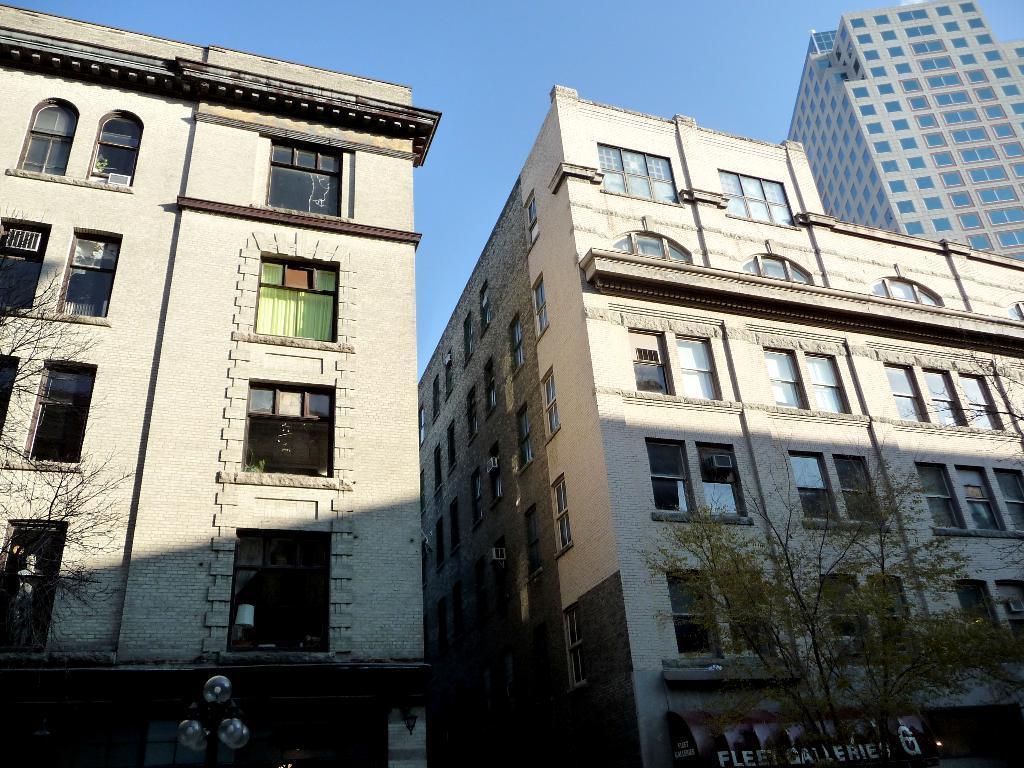Could you give a brief overview of what you see in this image? In this picture there is a white color building with glass windows. In the front bottom side there is a shop naming board and some dry plant. In the background we can see the tall white building. 